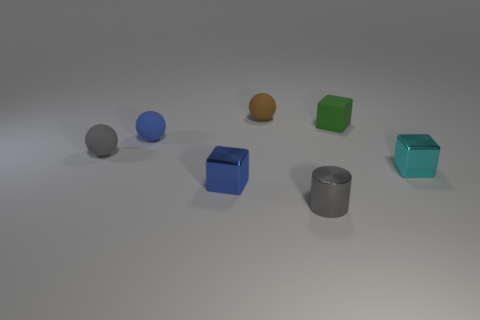Add 1 purple metallic blocks. How many objects exist? 8 Subtract all cylinders. How many objects are left? 6 Subtract 0 red spheres. How many objects are left? 7 Subtract all small red metal spheres. Subtract all blue spheres. How many objects are left? 6 Add 5 small cylinders. How many small cylinders are left? 6 Add 1 tiny matte spheres. How many tiny matte spheres exist? 4 